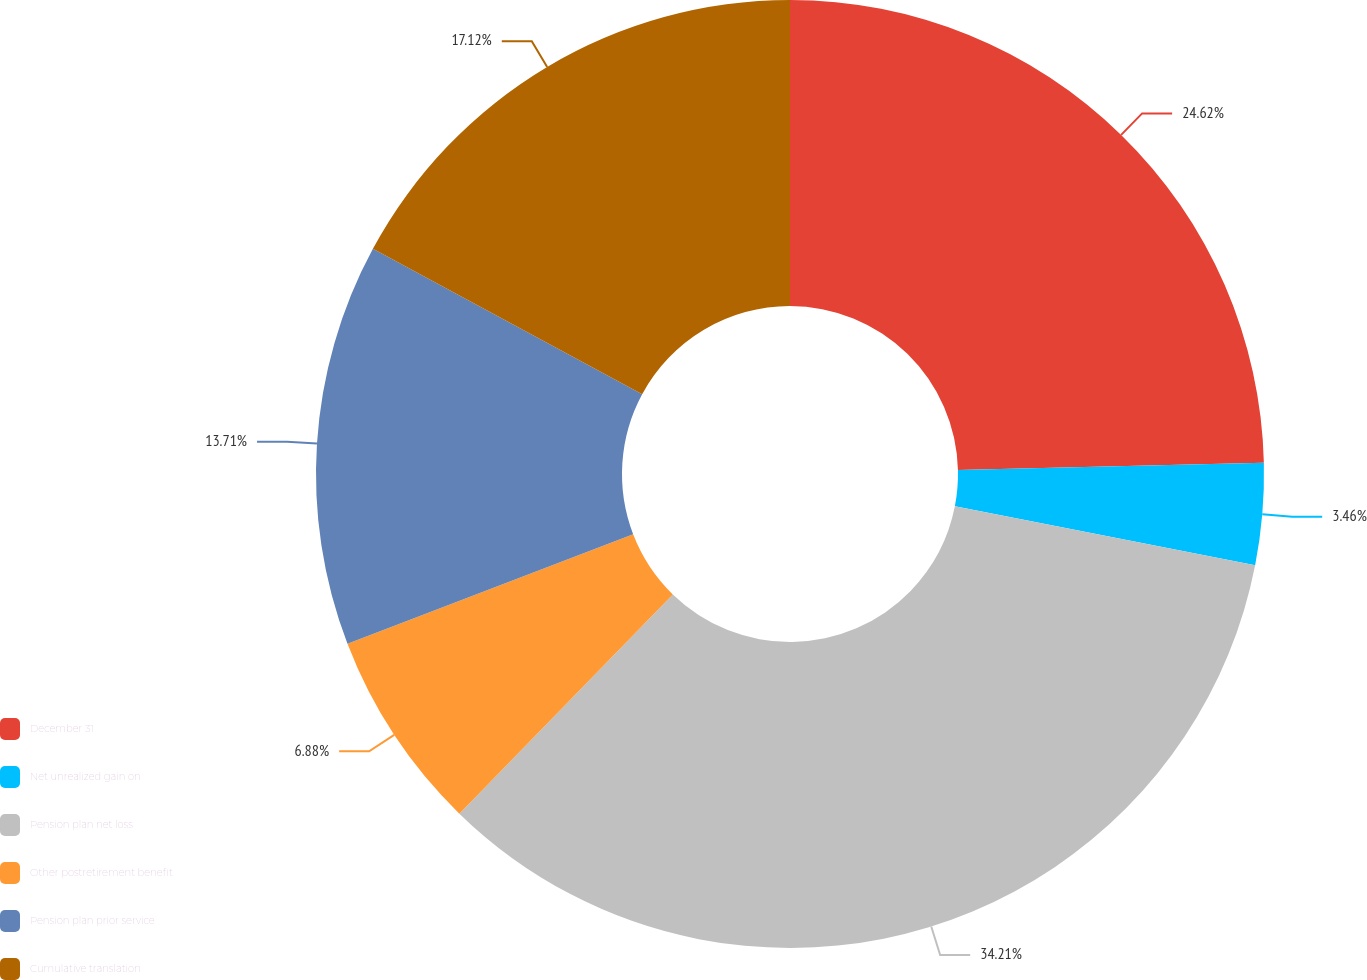<chart> <loc_0><loc_0><loc_500><loc_500><pie_chart><fcel>December 31<fcel>Net unrealized gain on<fcel>Pension plan net loss<fcel>Other postretirement benefit<fcel>Pension plan prior service<fcel>Cumulative translation<nl><fcel>24.62%<fcel>3.46%<fcel>34.2%<fcel>6.88%<fcel>13.71%<fcel>17.12%<nl></chart> 